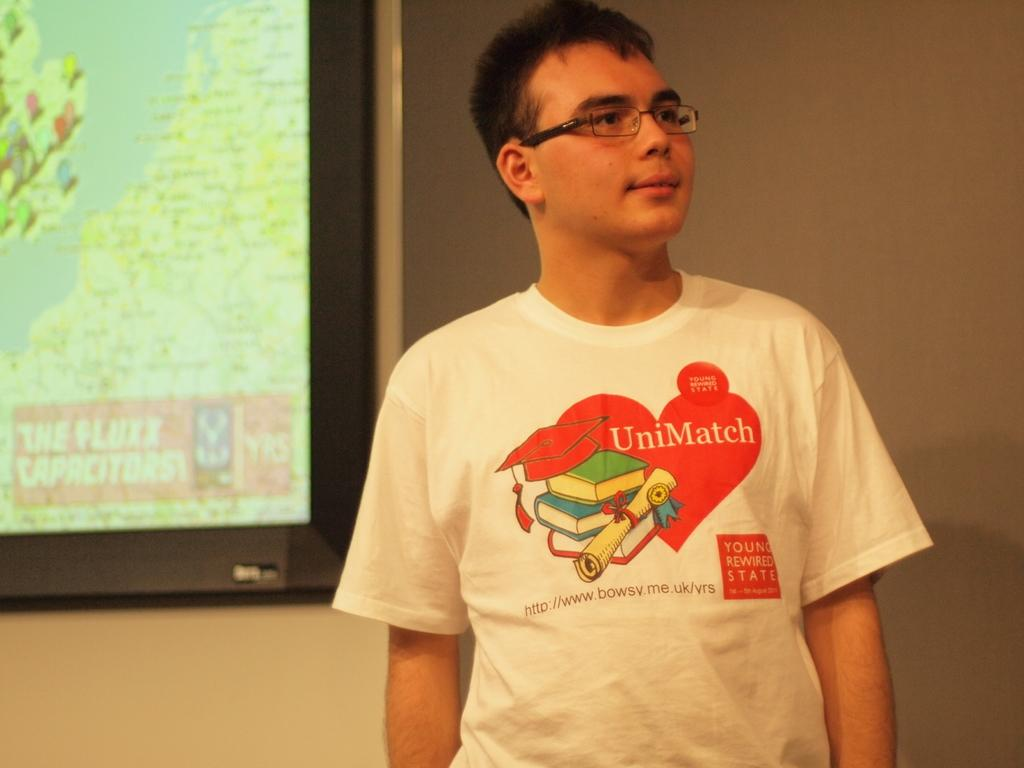What can be seen in the image? There is a person in the image. Can you describe the person's appearance? The person is wearing spectacles. What is the person doing in the image? The person is standing. What is visible in the background of the image? There is a wall and a board with images and text in the background of the image. How many babies are present in the image? There are no babies present in the image; it features a person wearing spectacles and standing in front of a wall and a board with images and text. 